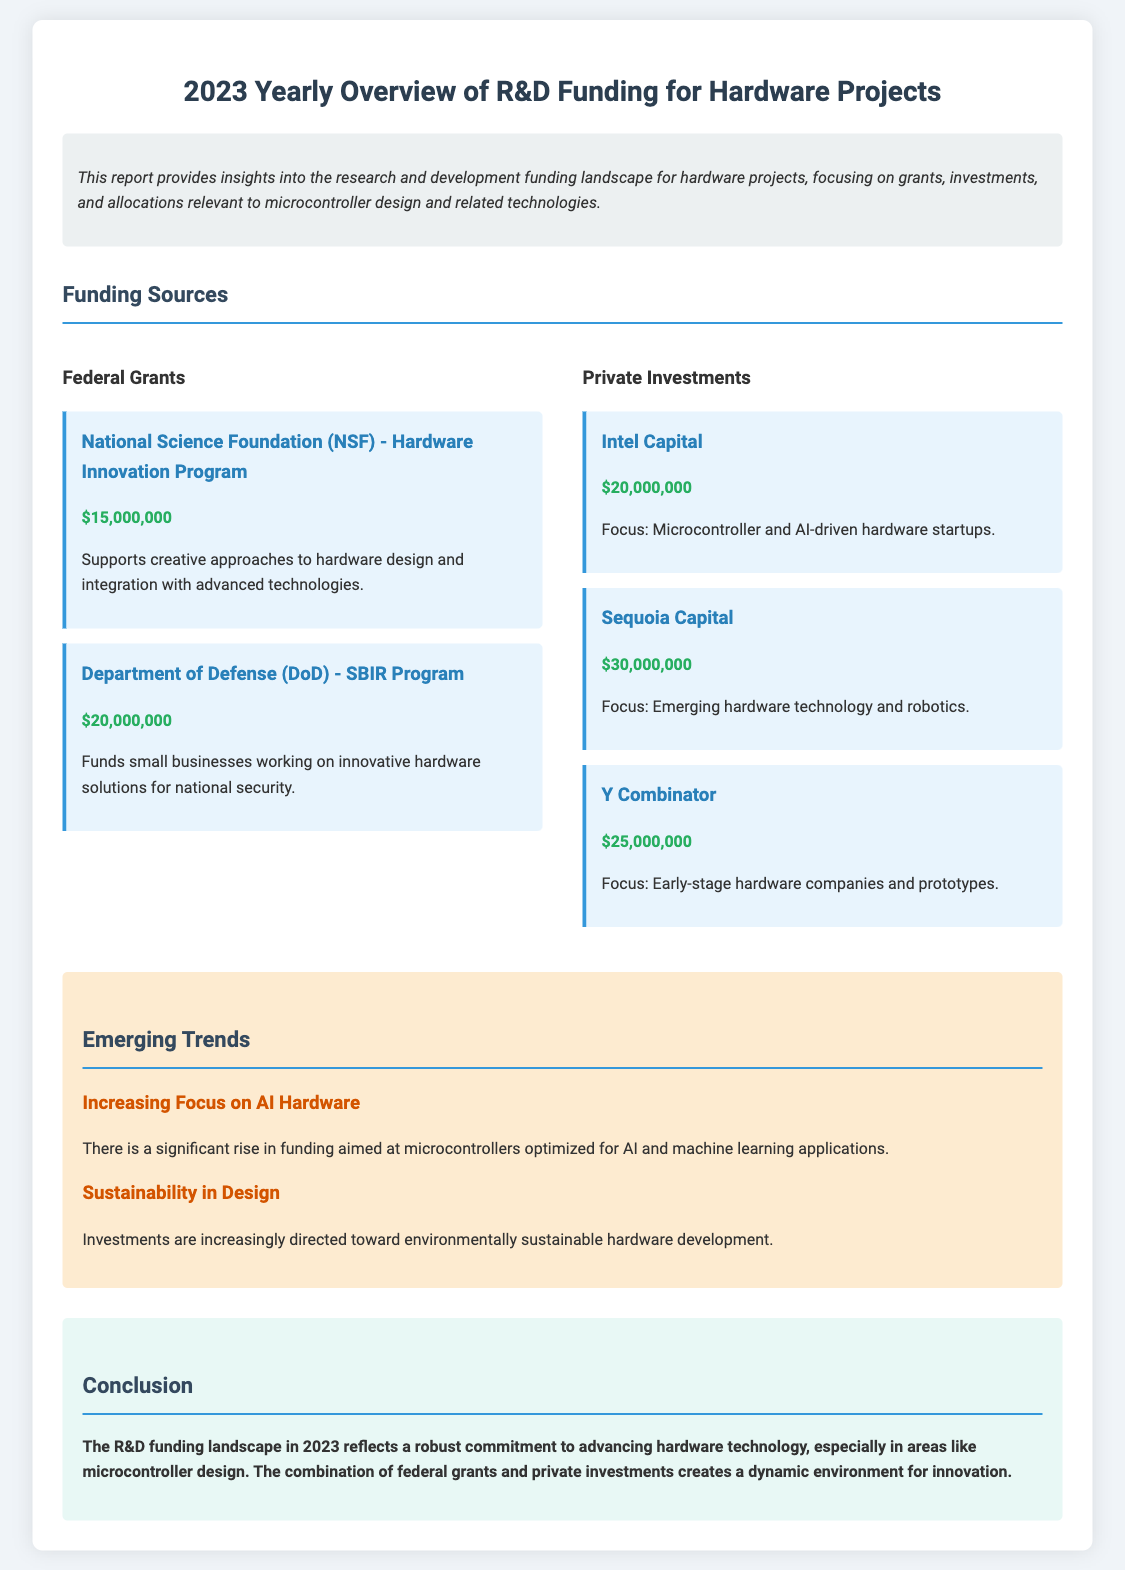What is the total funding from federal grants? The total funding from federal grants is the sum of NSF and DoD funds: $15,000,000 + $20,000,000 = $35,000,000.
Answer: $35,000,000 How much funding is allocated to Sequoia Capital? The funding allocated to Sequoia Capital is specified in the private investments section of the document.
Answer: $30,000,000 Which program is associated with the Department of Defense? This asks for the specific program mentioned in the federal grants section related to the Department of Defense.
Answer: SBIR Program What is a key trend mentioned in the report? This requires understanding the emerging trends section of the document.
Answer: Increasing Focus on AI Hardware How many private investments are mentioned? This asks for a count of distinct private investment sources listed in the document.
Answer: Three What is the main focus of Intel Capital's investment? This looks for the focus area highlighted under Intel Capital in the funding section.
Answer: Microcontroller and AI-driven hardware startups What year does this funding report pertain to? The year is explicitly mentioned in the title of the document.
Answer: 2023 What is the conclusion regarding R&D funding in hardware technology? This asks for the main takeaway from the conclusion section in the document.
Answer: A robust commitment to advancing hardware technology 